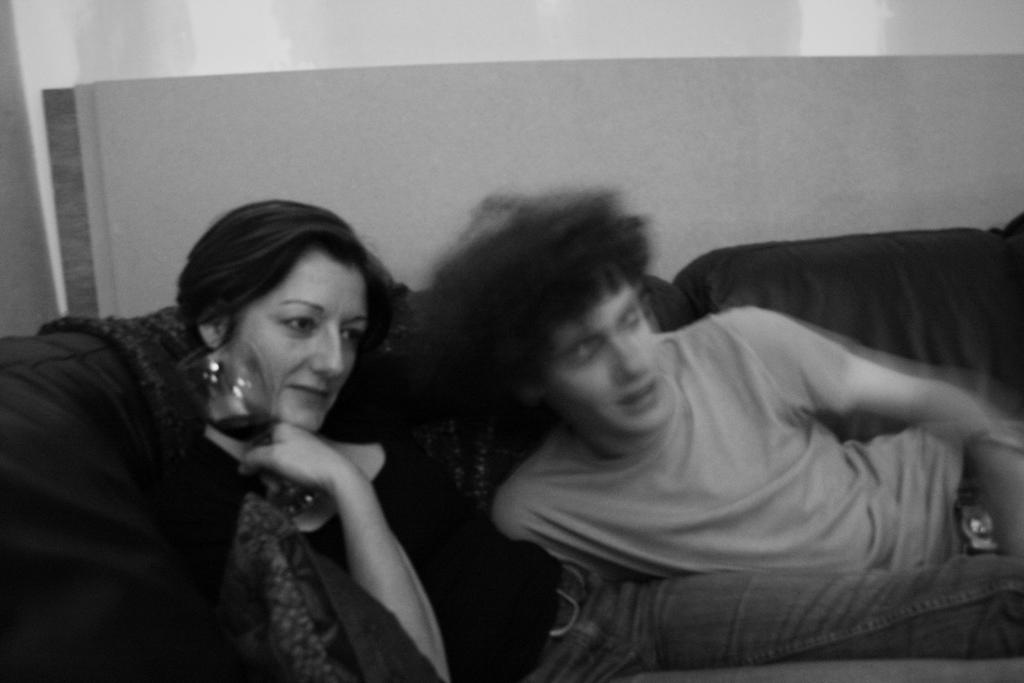What is the man doing in the image? The man is sitting on the sofa in the image. What is the woman doing in the image? The woman is sitting in the image and holding a glass. What can be seen in the background of the image? There is a wall visible in the background of the image. What type of clock is hanging on the wall in the image? There is no clock visible on the wall in the image. What level of experience does the beginner have in the image? There is no indication of any beginner or experience level in the image. 